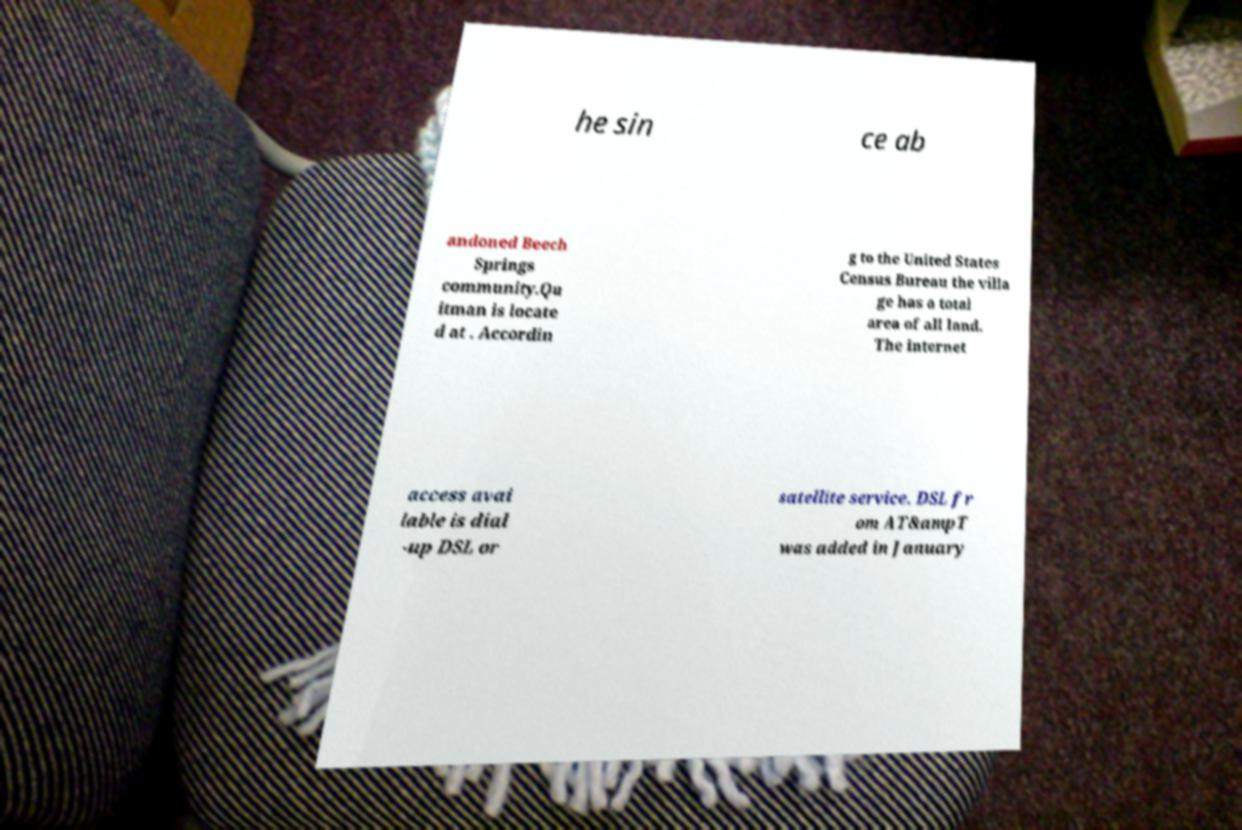Please identify and transcribe the text found in this image. he sin ce ab andoned Beech Springs community.Qu itman is locate d at . Accordin g to the United States Census Bureau the villa ge has a total area of all land. The internet access avai lable is dial -up DSL or satellite service. DSL fr om AT&ampT was added in January 